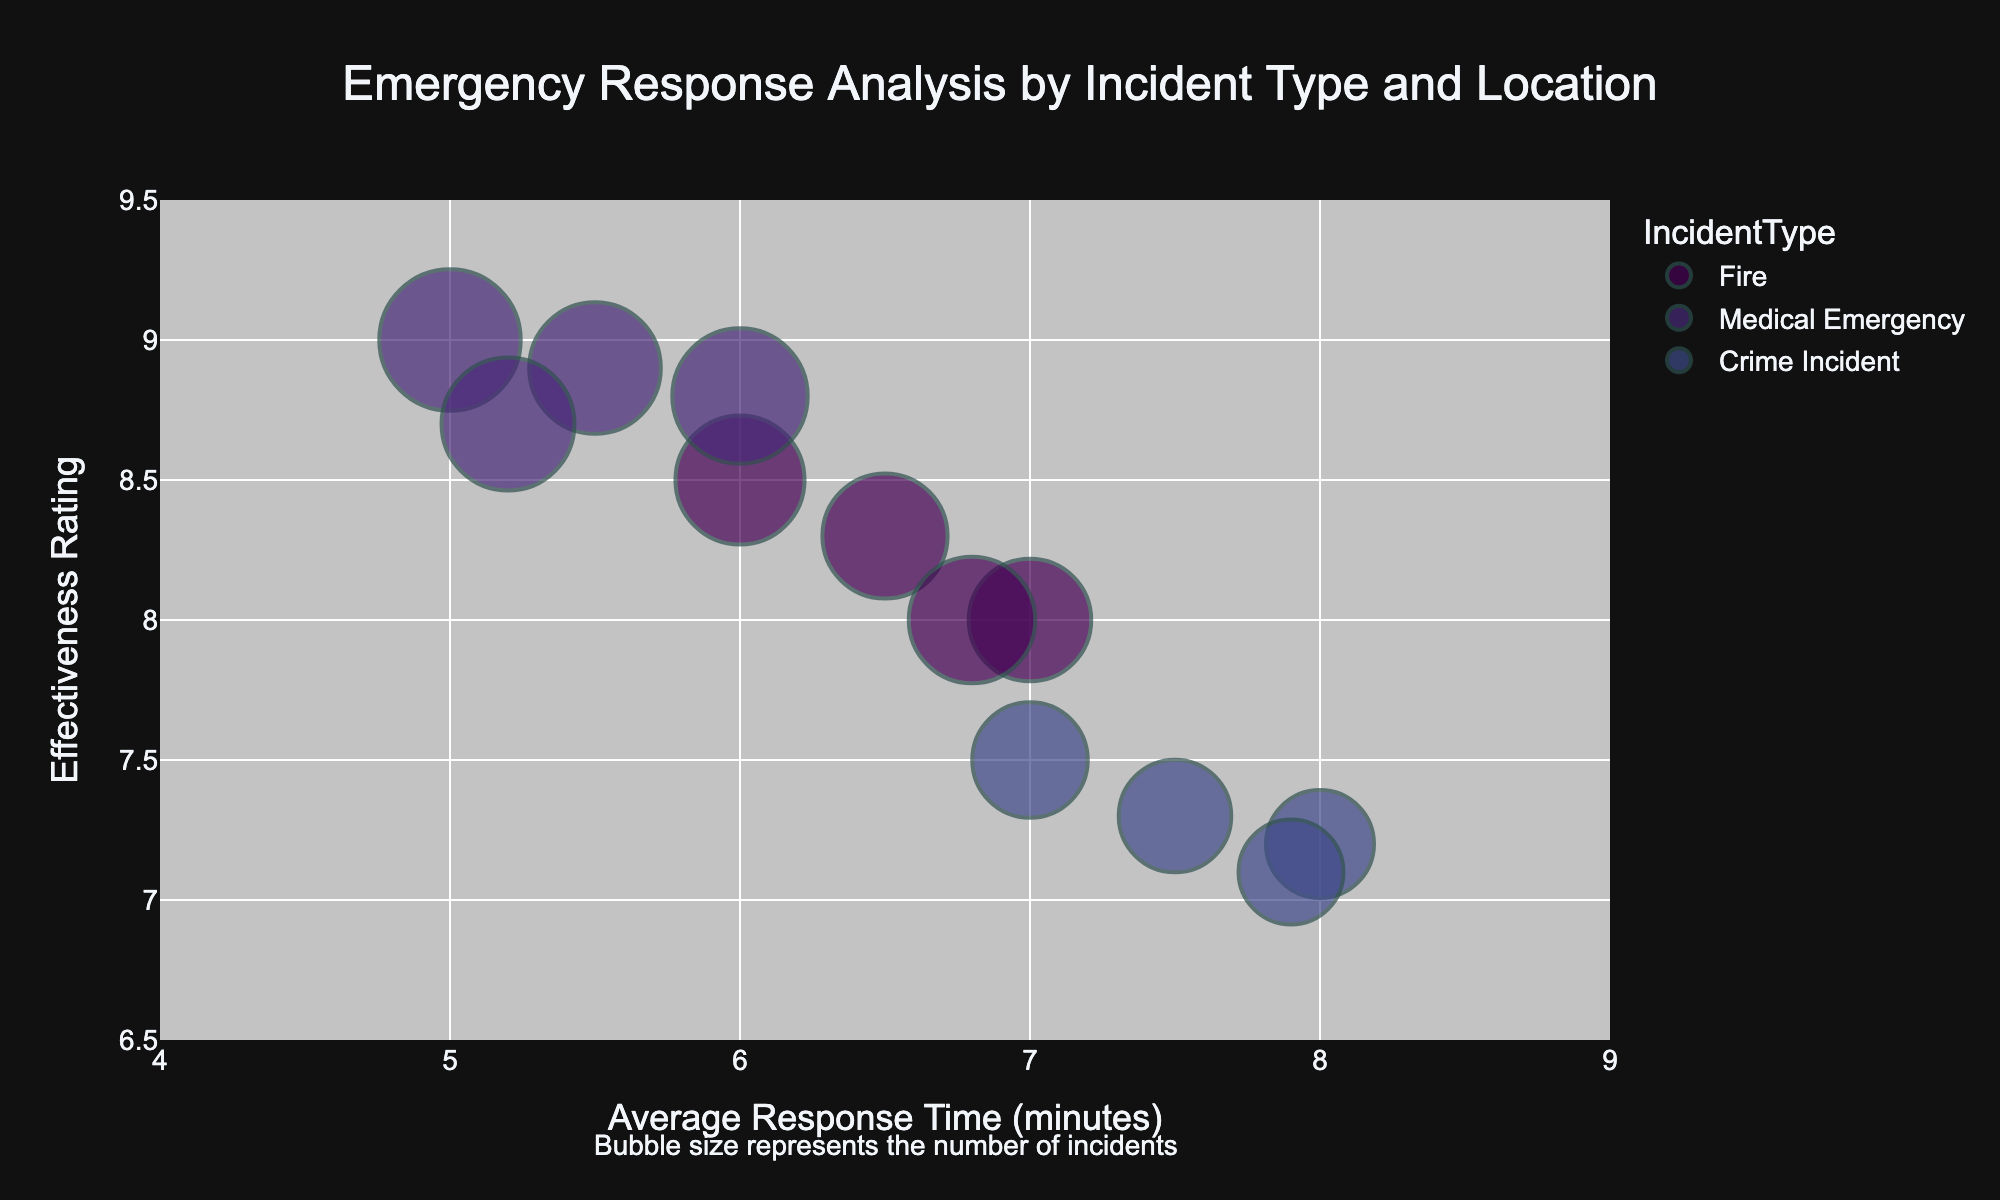what is the title of the figure? The title is located at the top of the figure and usually summarizes the main focus or purpose of the chart. In this diagram, it provides a description of what the chart is about.
Answer: Emergency Response Analysis by Incident Type and Location What does the size of each bubble represent? The annotation at the bottom of the chart mentions what the bubble size stands for. This annotation clarifies that the size is symbolic of a certain aspect.
Answer: The number of incidents Which city has the quickest average response time for medical emergencies? By looking at the x-axis labeled "Average Response Time (minutes)", identify the smallest value for the bubbles categorized under "Medical Emergency".
Answer: Houston What is the average response time for fire incidents in Chicago? Locate the bubble with the label "Fire" and "Chicago" on the x-axis for "Average Response Time (minutes)".
Answer: 6.5 minutes Which incident type in New York has the highest effectiveness rating? Check the y-axis labeled "Effectiveness Rating" and find the highest value among the New York bubbles distinguished by different colors for each incident type.
Answer: Medical Emergency Compare the effectiveness rating between Crime Incidents in New York and Los Angeles. Find and compare the y-axis values for "Crime Incident" bubbles in New York and Los Angeles. New York's bubble has a rating of 7.5, and Los Angeles' bubble has a rating of 7.2.
Answer: New York has a higher rating than Los Angeles In which city do crime incidents have the longest average response time? Look at the "Crime Incident" bubbles and compare their positions on the x-axis. Identify the city corresponding to the bubble with the highest value on the x-axis.
Answer: Houston What are the two cities with the most similar response times for medical emergencies? Locate the "Medical Emergency" bubbles and examine their x-axis positions. The bubbles with the most similar x-axis values will indicate the cities with close response times.
Answer: Chicago and Los Angeles How does the effectiveness rating for Fire incidents in Los Angeles compare with the same for Chicago? Check the y-axis value of the "Fire" bubbles in Los Angeles and Chicago. Los Angeles has a rating of 8, whereas Chicago's is 8.3.
Answer: Chicago has a slightly higher effectiveness rating than Los Angeles Which incident type in Houston has the highest number of incidents? Observing the bubble sizes for different incident types in Houston, the largest bubble represents the highest number of incidents. The medical emergency bubble is the largest.
Answer: Medical Emergency 